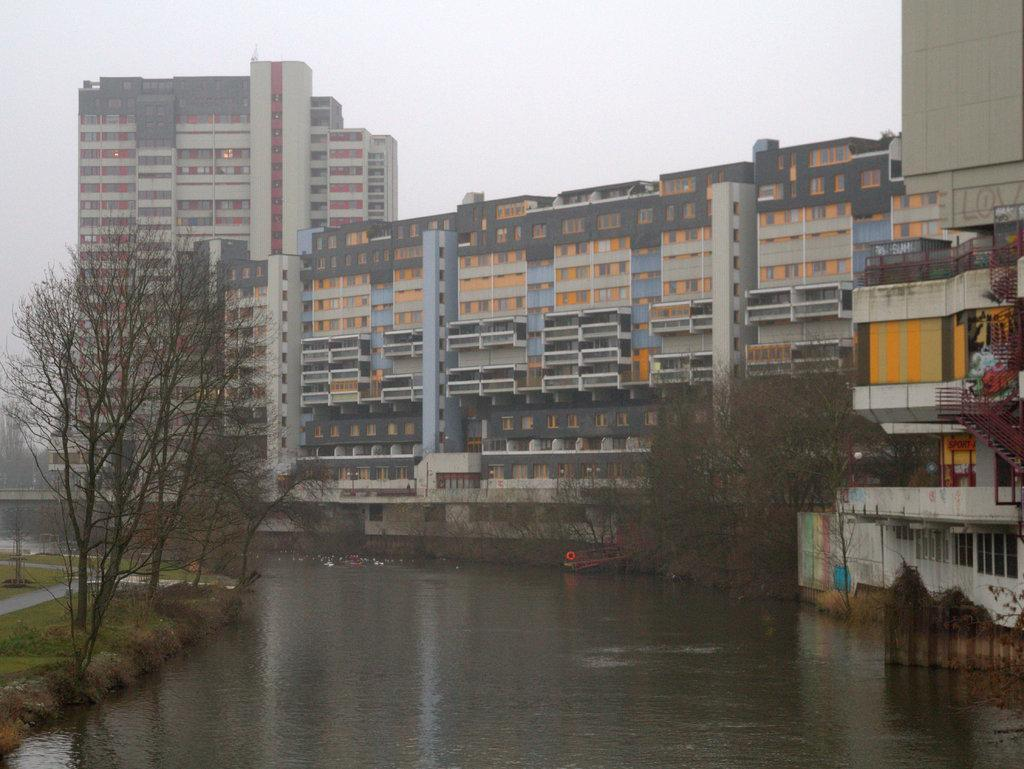What type of vegetation can be seen in the image? There are trees in the image. What else can be seen besides trees? There is water, grass, a road, and stairs visible in the image. What is visible in the sky in the image? The sky is visible in the image. Can you hear the whistle of the wind in the image? There is no mention of wind or a whistle in the image, so it cannot be heard. What is located at the back of the image? The provided facts do not mention anything specific about the back of the image, so we cannot determine what is located there. 